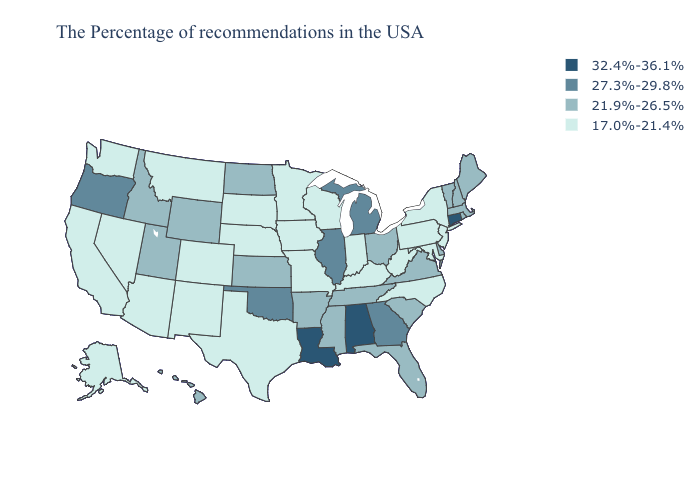Name the states that have a value in the range 27.3%-29.8%?
Be succinct. Georgia, Michigan, Illinois, Oklahoma, Oregon. What is the value of Louisiana?
Write a very short answer. 32.4%-36.1%. Name the states that have a value in the range 32.4%-36.1%?
Short answer required. Connecticut, Alabama, Louisiana. What is the value of Maryland?
Write a very short answer. 17.0%-21.4%. What is the lowest value in the USA?
Write a very short answer. 17.0%-21.4%. Does Maryland have the lowest value in the USA?
Keep it brief. Yes. Which states have the lowest value in the USA?
Short answer required. New York, New Jersey, Maryland, Pennsylvania, North Carolina, West Virginia, Kentucky, Indiana, Wisconsin, Missouri, Minnesota, Iowa, Nebraska, Texas, South Dakota, Colorado, New Mexico, Montana, Arizona, Nevada, California, Washington, Alaska. Is the legend a continuous bar?
Quick response, please. No. Name the states that have a value in the range 27.3%-29.8%?
Concise answer only. Georgia, Michigan, Illinois, Oklahoma, Oregon. Name the states that have a value in the range 32.4%-36.1%?
Answer briefly. Connecticut, Alabama, Louisiana. Among the states that border South Dakota , which have the highest value?
Keep it brief. North Dakota, Wyoming. Does South Carolina have the same value as Kansas?
Concise answer only. Yes. Does Iowa have the lowest value in the MidWest?
Answer briefly. Yes. 